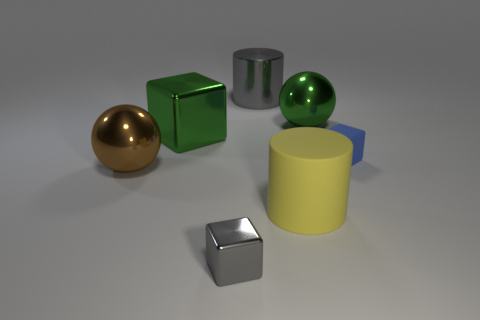Is there a large block that has the same material as the large gray thing?
Offer a terse response. Yes. The blue cube has what size?
Keep it short and to the point. Small. There is a green thing that is right of the cube in front of the large yellow matte object; what size is it?
Offer a terse response. Large. There is a large green object that is the same shape as the large brown shiny object; what is it made of?
Provide a succinct answer. Metal. How many blue blocks are there?
Your answer should be very brief. 1. There is a metallic cube behind the small thing on the right side of the matte object to the left of the big green shiny ball; what color is it?
Offer a very short reply. Green. Is the number of large objects less than the number of blue metallic objects?
Your answer should be compact. No. What color is the other small metallic thing that is the same shape as the tiny blue thing?
Offer a very short reply. Gray. What is the color of the other sphere that is the same material as the big green ball?
Make the answer very short. Brown. How many gray metallic cylinders are the same size as the yellow cylinder?
Ensure brevity in your answer.  1. 